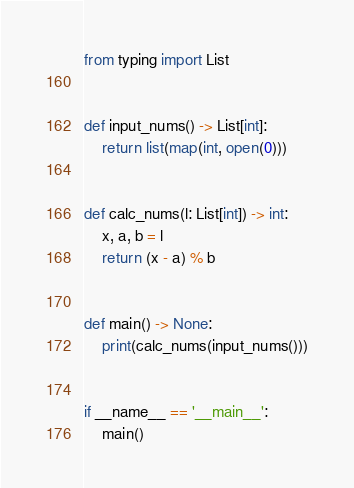Convert code to text. <code><loc_0><loc_0><loc_500><loc_500><_Python_>from typing import List


def input_nums() -> List[int]:
    return list(map(int, open(0)))


def calc_nums(l: List[int]) -> int:
    x, a, b = l
    return (x - a) % b


def main() -> None:
    print(calc_nums(input_nums()))


if __name__ == '__main__':
    main()</code> 